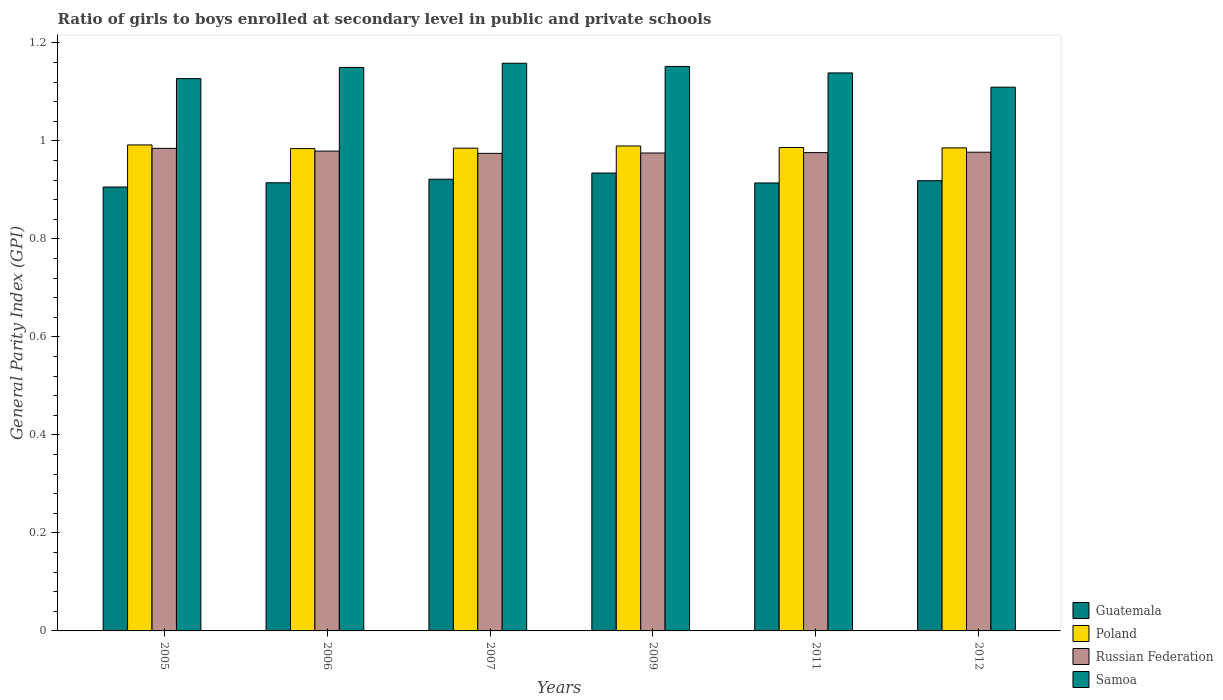How many different coloured bars are there?
Keep it short and to the point. 4. What is the label of the 6th group of bars from the left?
Your response must be concise. 2012. In how many cases, is the number of bars for a given year not equal to the number of legend labels?
Offer a terse response. 0. What is the general parity index in Poland in 2011?
Give a very brief answer. 0.99. Across all years, what is the maximum general parity index in Guatemala?
Offer a very short reply. 0.93. Across all years, what is the minimum general parity index in Guatemala?
Ensure brevity in your answer.  0.91. In which year was the general parity index in Guatemala minimum?
Make the answer very short. 2005. What is the total general parity index in Poland in the graph?
Give a very brief answer. 5.92. What is the difference between the general parity index in Russian Federation in 2006 and that in 2012?
Provide a succinct answer. 0. What is the difference between the general parity index in Samoa in 2007 and the general parity index in Russian Federation in 2011?
Make the answer very short. 0.18. What is the average general parity index in Samoa per year?
Offer a terse response. 1.14. In the year 2005, what is the difference between the general parity index in Poland and general parity index in Russian Federation?
Offer a terse response. 0.01. In how many years, is the general parity index in Guatemala greater than 1.04?
Ensure brevity in your answer.  0. What is the ratio of the general parity index in Russian Federation in 2009 to that in 2011?
Keep it short and to the point. 1. Is the difference between the general parity index in Poland in 2007 and 2009 greater than the difference between the general parity index in Russian Federation in 2007 and 2009?
Make the answer very short. No. What is the difference between the highest and the second highest general parity index in Poland?
Your response must be concise. 0. What is the difference between the highest and the lowest general parity index in Guatemala?
Give a very brief answer. 0.03. In how many years, is the general parity index in Poland greater than the average general parity index in Poland taken over all years?
Provide a succinct answer. 2. Is the sum of the general parity index in Russian Federation in 2009 and 2011 greater than the maximum general parity index in Guatemala across all years?
Your answer should be compact. Yes. What does the 1st bar from the left in 2011 represents?
Your answer should be compact. Guatemala. What does the 3rd bar from the right in 2011 represents?
Ensure brevity in your answer.  Poland. What is the difference between two consecutive major ticks on the Y-axis?
Ensure brevity in your answer.  0.2. How many legend labels are there?
Make the answer very short. 4. How are the legend labels stacked?
Your answer should be compact. Vertical. What is the title of the graph?
Provide a short and direct response. Ratio of girls to boys enrolled at secondary level in public and private schools. Does "Channel Islands" appear as one of the legend labels in the graph?
Offer a terse response. No. What is the label or title of the X-axis?
Ensure brevity in your answer.  Years. What is the label or title of the Y-axis?
Give a very brief answer. General Parity Index (GPI). What is the General Parity Index (GPI) in Guatemala in 2005?
Offer a very short reply. 0.91. What is the General Parity Index (GPI) of Poland in 2005?
Your response must be concise. 0.99. What is the General Parity Index (GPI) of Russian Federation in 2005?
Provide a succinct answer. 0.98. What is the General Parity Index (GPI) in Samoa in 2005?
Offer a terse response. 1.13. What is the General Parity Index (GPI) of Guatemala in 2006?
Provide a short and direct response. 0.91. What is the General Parity Index (GPI) of Poland in 2006?
Provide a succinct answer. 0.98. What is the General Parity Index (GPI) of Russian Federation in 2006?
Provide a succinct answer. 0.98. What is the General Parity Index (GPI) of Samoa in 2006?
Your response must be concise. 1.15. What is the General Parity Index (GPI) of Guatemala in 2007?
Your response must be concise. 0.92. What is the General Parity Index (GPI) of Poland in 2007?
Offer a very short reply. 0.99. What is the General Parity Index (GPI) of Russian Federation in 2007?
Make the answer very short. 0.97. What is the General Parity Index (GPI) of Samoa in 2007?
Offer a very short reply. 1.16. What is the General Parity Index (GPI) of Guatemala in 2009?
Give a very brief answer. 0.93. What is the General Parity Index (GPI) in Poland in 2009?
Your answer should be compact. 0.99. What is the General Parity Index (GPI) of Russian Federation in 2009?
Offer a very short reply. 0.98. What is the General Parity Index (GPI) of Samoa in 2009?
Your response must be concise. 1.15. What is the General Parity Index (GPI) in Guatemala in 2011?
Offer a very short reply. 0.91. What is the General Parity Index (GPI) in Poland in 2011?
Offer a very short reply. 0.99. What is the General Parity Index (GPI) of Russian Federation in 2011?
Your answer should be compact. 0.98. What is the General Parity Index (GPI) of Samoa in 2011?
Give a very brief answer. 1.14. What is the General Parity Index (GPI) of Guatemala in 2012?
Ensure brevity in your answer.  0.92. What is the General Parity Index (GPI) in Poland in 2012?
Make the answer very short. 0.99. What is the General Parity Index (GPI) of Russian Federation in 2012?
Your response must be concise. 0.98. What is the General Parity Index (GPI) in Samoa in 2012?
Ensure brevity in your answer.  1.11. Across all years, what is the maximum General Parity Index (GPI) in Guatemala?
Make the answer very short. 0.93. Across all years, what is the maximum General Parity Index (GPI) in Poland?
Provide a succinct answer. 0.99. Across all years, what is the maximum General Parity Index (GPI) in Russian Federation?
Provide a short and direct response. 0.98. Across all years, what is the maximum General Parity Index (GPI) of Samoa?
Offer a terse response. 1.16. Across all years, what is the minimum General Parity Index (GPI) in Guatemala?
Ensure brevity in your answer.  0.91. Across all years, what is the minimum General Parity Index (GPI) in Poland?
Give a very brief answer. 0.98. Across all years, what is the minimum General Parity Index (GPI) of Russian Federation?
Give a very brief answer. 0.97. Across all years, what is the minimum General Parity Index (GPI) in Samoa?
Provide a short and direct response. 1.11. What is the total General Parity Index (GPI) in Guatemala in the graph?
Provide a succinct answer. 5.51. What is the total General Parity Index (GPI) in Poland in the graph?
Make the answer very short. 5.92. What is the total General Parity Index (GPI) of Russian Federation in the graph?
Make the answer very short. 5.87. What is the total General Parity Index (GPI) of Samoa in the graph?
Your answer should be compact. 6.84. What is the difference between the General Parity Index (GPI) in Guatemala in 2005 and that in 2006?
Your response must be concise. -0.01. What is the difference between the General Parity Index (GPI) in Poland in 2005 and that in 2006?
Provide a short and direct response. 0.01. What is the difference between the General Parity Index (GPI) in Russian Federation in 2005 and that in 2006?
Offer a very short reply. 0.01. What is the difference between the General Parity Index (GPI) in Samoa in 2005 and that in 2006?
Make the answer very short. -0.02. What is the difference between the General Parity Index (GPI) of Guatemala in 2005 and that in 2007?
Offer a terse response. -0.02. What is the difference between the General Parity Index (GPI) in Poland in 2005 and that in 2007?
Keep it short and to the point. 0.01. What is the difference between the General Parity Index (GPI) of Russian Federation in 2005 and that in 2007?
Make the answer very short. 0.01. What is the difference between the General Parity Index (GPI) in Samoa in 2005 and that in 2007?
Offer a terse response. -0.03. What is the difference between the General Parity Index (GPI) in Guatemala in 2005 and that in 2009?
Give a very brief answer. -0.03. What is the difference between the General Parity Index (GPI) in Poland in 2005 and that in 2009?
Make the answer very short. 0. What is the difference between the General Parity Index (GPI) in Russian Federation in 2005 and that in 2009?
Give a very brief answer. 0.01. What is the difference between the General Parity Index (GPI) of Samoa in 2005 and that in 2009?
Offer a terse response. -0.02. What is the difference between the General Parity Index (GPI) in Guatemala in 2005 and that in 2011?
Your response must be concise. -0.01. What is the difference between the General Parity Index (GPI) in Poland in 2005 and that in 2011?
Your response must be concise. 0.01. What is the difference between the General Parity Index (GPI) in Russian Federation in 2005 and that in 2011?
Make the answer very short. 0.01. What is the difference between the General Parity Index (GPI) in Samoa in 2005 and that in 2011?
Offer a very short reply. -0.01. What is the difference between the General Parity Index (GPI) in Guatemala in 2005 and that in 2012?
Your answer should be very brief. -0.01. What is the difference between the General Parity Index (GPI) of Poland in 2005 and that in 2012?
Provide a short and direct response. 0.01. What is the difference between the General Parity Index (GPI) in Russian Federation in 2005 and that in 2012?
Offer a very short reply. 0.01. What is the difference between the General Parity Index (GPI) in Samoa in 2005 and that in 2012?
Give a very brief answer. 0.02. What is the difference between the General Parity Index (GPI) in Guatemala in 2006 and that in 2007?
Provide a succinct answer. -0.01. What is the difference between the General Parity Index (GPI) of Poland in 2006 and that in 2007?
Your response must be concise. -0. What is the difference between the General Parity Index (GPI) of Russian Federation in 2006 and that in 2007?
Keep it short and to the point. 0. What is the difference between the General Parity Index (GPI) in Samoa in 2006 and that in 2007?
Provide a short and direct response. -0.01. What is the difference between the General Parity Index (GPI) of Guatemala in 2006 and that in 2009?
Give a very brief answer. -0.02. What is the difference between the General Parity Index (GPI) of Poland in 2006 and that in 2009?
Give a very brief answer. -0.01. What is the difference between the General Parity Index (GPI) in Russian Federation in 2006 and that in 2009?
Offer a terse response. 0. What is the difference between the General Parity Index (GPI) in Samoa in 2006 and that in 2009?
Keep it short and to the point. -0. What is the difference between the General Parity Index (GPI) of Guatemala in 2006 and that in 2011?
Provide a short and direct response. 0. What is the difference between the General Parity Index (GPI) of Poland in 2006 and that in 2011?
Give a very brief answer. -0. What is the difference between the General Parity Index (GPI) in Russian Federation in 2006 and that in 2011?
Offer a very short reply. 0. What is the difference between the General Parity Index (GPI) of Samoa in 2006 and that in 2011?
Your response must be concise. 0.01. What is the difference between the General Parity Index (GPI) of Guatemala in 2006 and that in 2012?
Offer a very short reply. -0. What is the difference between the General Parity Index (GPI) of Poland in 2006 and that in 2012?
Your response must be concise. -0. What is the difference between the General Parity Index (GPI) in Russian Federation in 2006 and that in 2012?
Provide a short and direct response. 0. What is the difference between the General Parity Index (GPI) of Samoa in 2006 and that in 2012?
Offer a very short reply. 0.04. What is the difference between the General Parity Index (GPI) of Guatemala in 2007 and that in 2009?
Your response must be concise. -0.01. What is the difference between the General Parity Index (GPI) of Poland in 2007 and that in 2009?
Give a very brief answer. -0. What is the difference between the General Parity Index (GPI) in Russian Federation in 2007 and that in 2009?
Your response must be concise. -0. What is the difference between the General Parity Index (GPI) of Samoa in 2007 and that in 2009?
Your answer should be very brief. 0.01. What is the difference between the General Parity Index (GPI) in Guatemala in 2007 and that in 2011?
Offer a very short reply. 0.01. What is the difference between the General Parity Index (GPI) in Poland in 2007 and that in 2011?
Provide a succinct answer. -0. What is the difference between the General Parity Index (GPI) of Russian Federation in 2007 and that in 2011?
Your answer should be compact. -0. What is the difference between the General Parity Index (GPI) in Samoa in 2007 and that in 2011?
Give a very brief answer. 0.02. What is the difference between the General Parity Index (GPI) in Guatemala in 2007 and that in 2012?
Your answer should be compact. 0. What is the difference between the General Parity Index (GPI) of Poland in 2007 and that in 2012?
Offer a terse response. -0. What is the difference between the General Parity Index (GPI) of Russian Federation in 2007 and that in 2012?
Your response must be concise. -0. What is the difference between the General Parity Index (GPI) of Samoa in 2007 and that in 2012?
Offer a terse response. 0.05. What is the difference between the General Parity Index (GPI) of Guatemala in 2009 and that in 2011?
Give a very brief answer. 0.02. What is the difference between the General Parity Index (GPI) in Poland in 2009 and that in 2011?
Offer a very short reply. 0. What is the difference between the General Parity Index (GPI) in Russian Federation in 2009 and that in 2011?
Ensure brevity in your answer.  -0. What is the difference between the General Parity Index (GPI) of Samoa in 2009 and that in 2011?
Give a very brief answer. 0.01. What is the difference between the General Parity Index (GPI) in Guatemala in 2009 and that in 2012?
Ensure brevity in your answer.  0.02. What is the difference between the General Parity Index (GPI) of Poland in 2009 and that in 2012?
Your answer should be very brief. 0. What is the difference between the General Parity Index (GPI) of Russian Federation in 2009 and that in 2012?
Offer a terse response. -0. What is the difference between the General Parity Index (GPI) in Samoa in 2009 and that in 2012?
Your answer should be compact. 0.04. What is the difference between the General Parity Index (GPI) in Guatemala in 2011 and that in 2012?
Make the answer very short. -0. What is the difference between the General Parity Index (GPI) of Poland in 2011 and that in 2012?
Your response must be concise. 0. What is the difference between the General Parity Index (GPI) of Russian Federation in 2011 and that in 2012?
Your answer should be very brief. -0. What is the difference between the General Parity Index (GPI) in Samoa in 2011 and that in 2012?
Keep it short and to the point. 0.03. What is the difference between the General Parity Index (GPI) in Guatemala in 2005 and the General Parity Index (GPI) in Poland in 2006?
Provide a short and direct response. -0.08. What is the difference between the General Parity Index (GPI) of Guatemala in 2005 and the General Parity Index (GPI) of Russian Federation in 2006?
Provide a short and direct response. -0.07. What is the difference between the General Parity Index (GPI) in Guatemala in 2005 and the General Parity Index (GPI) in Samoa in 2006?
Give a very brief answer. -0.24. What is the difference between the General Parity Index (GPI) in Poland in 2005 and the General Parity Index (GPI) in Russian Federation in 2006?
Ensure brevity in your answer.  0.01. What is the difference between the General Parity Index (GPI) of Poland in 2005 and the General Parity Index (GPI) of Samoa in 2006?
Make the answer very short. -0.16. What is the difference between the General Parity Index (GPI) in Russian Federation in 2005 and the General Parity Index (GPI) in Samoa in 2006?
Ensure brevity in your answer.  -0.17. What is the difference between the General Parity Index (GPI) of Guatemala in 2005 and the General Parity Index (GPI) of Poland in 2007?
Your answer should be very brief. -0.08. What is the difference between the General Parity Index (GPI) of Guatemala in 2005 and the General Parity Index (GPI) of Russian Federation in 2007?
Make the answer very short. -0.07. What is the difference between the General Parity Index (GPI) in Guatemala in 2005 and the General Parity Index (GPI) in Samoa in 2007?
Provide a succinct answer. -0.25. What is the difference between the General Parity Index (GPI) in Poland in 2005 and the General Parity Index (GPI) in Russian Federation in 2007?
Give a very brief answer. 0.02. What is the difference between the General Parity Index (GPI) of Poland in 2005 and the General Parity Index (GPI) of Samoa in 2007?
Your answer should be very brief. -0.17. What is the difference between the General Parity Index (GPI) in Russian Federation in 2005 and the General Parity Index (GPI) in Samoa in 2007?
Your answer should be compact. -0.17. What is the difference between the General Parity Index (GPI) of Guatemala in 2005 and the General Parity Index (GPI) of Poland in 2009?
Make the answer very short. -0.08. What is the difference between the General Parity Index (GPI) in Guatemala in 2005 and the General Parity Index (GPI) in Russian Federation in 2009?
Keep it short and to the point. -0.07. What is the difference between the General Parity Index (GPI) of Guatemala in 2005 and the General Parity Index (GPI) of Samoa in 2009?
Give a very brief answer. -0.25. What is the difference between the General Parity Index (GPI) of Poland in 2005 and the General Parity Index (GPI) of Russian Federation in 2009?
Keep it short and to the point. 0.02. What is the difference between the General Parity Index (GPI) in Poland in 2005 and the General Parity Index (GPI) in Samoa in 2009?
Provide a succinct answer. -0.16. What is the difference between the General Parity Index (GPI) of Russian Federation in 2005 and the General Parity Index (GPI) of Samoa in 2009?
Keep it short and to the point. -0.17. What is the difference between the General Parity Index (GPI) of Guatemala in 2005 and the General Parity Index (GPI) of Poland in 2011?
Provide a short and direct response. -0.08. What is the difference between the General Parity Index (GPI) of Guatemala in 2005 and the General Parity Index (GPI) of Russian Federation in 2011?
Your response must be concise. -0.07. What is the difference between the General Parity Index (GPI) in Guatemala in 2005 and the General Parity Index (GPI) in Samoa in 2011?
Offer a terse response. -0.23. What is the difference between the General Parity Index (GPI) of Poland in 2005 and the General Parity Index (GPI) of Russian Federation in 2011?
Make the answer very short. 0.02. What is the difference between the General Parity Index (GPI) in Poland in 2005 and the General Parity Index (GPI) in Samoa in 2011?
Offer a terse response. -0.15. What is the difference between the General Parity Index (GPI) of Russian Federation in 2005 and the General Parity Index (GPI) of Samoa in 2011?
Ensure brevity in your answer.  -0.15. What is the difference between the General Parity Index (GPI) in Guatemala in 2005 and the General Parity Index (GPI) in Poland in 2012?
Provide a succinct answer. -0.08. What is the difference between the General Parity Index (GPI) of Guatemala in 2005 and the General Parity Index (GPI) of Russian Federation in 2012?
Make the answer very short. -0.07. What is the difference between the General Parity Index (GPI) in Guatemala in 2005 and the General Parity Index (GPI) in Samoa in 2012?
Offer a terse response. -0.2. What is the difference between the General Parity Index (GPI) in Poland in 2005 and the General Parity Index (GPI) in Russian Federation in 2012?
Provide a short and direct response. 0.01. What is the difference between the General Parity Index (GPI) in Poland in 2005 and the General Parity Index (GPI) in Samoa in 2012?
Keep it short and to the point. -0.12. What is the difference between the General Parity Index (GPI) in Russian Federation in 2005 and the General Parity Index (GPI) in Samoa in 2012?
Your answer should be compact. -0.12. What is the difference between the General Parity Index (GPI) of Guatemala in 2006 and the General Parity Index (GPI) of Poland in 2007?
Keep it short and to the point. -0.07. What is the difference between the General Parity Index (GPI) of Guatemala in 2006 and the General Parity Index (GPI) of Russian Federation in 2007?
Give a very brief answer. -0.06. What is the difference between the General Parity Index (GPI) of Guatemala in 2006 and the General Parity Index (GPI) of Samoa in 2007?
Keep it short and to the point. -0.24. What is the difference between the General Parity Index (GPI) in Poland in 2006 and the General Parity Index (GPI) in Russian Federation in 2007?
Give a very brief answer. 0.01. What is the difference between the General Parity Index (GPI) of Poland in 2006 and the General Parity Index (GPI) of Samoa in 2007?
Keep it short and to the point. -0.17. What is the difference between the General Parity Index (GPI) of Russian Federation in 2006 and the General Parity Index (GPI) of Samoa in 2007?
Your answer should be very brief. -0.18. What is the difference between the General Parity Index (GPI) in Guatemala in 2006 and the General Parity Index (GPI) in Poland in 2009?
Give a very brief answer. -0.08. What is the difference between the General Parity Index (GPI) of Guatemala in 2006 and the General Parity Index (GPI) of Russian Federation in 2009?
Offer a terse response. -0.06. What is the difference between the General Parity Index (GPI) in Guatemala in 2006 and the General Parity Index (GPI) in Samoa in 2009?
Provide a succinct answer. -0.24. What is the difference between the General Parity Index (GPI) of Poland in 2006 and the General Parity Index (GPI) of Russian Federation in 2009?
Your response must be concise. 0.01. What is the difference between the General Parity Index (GPI) in Poland in 2006 and the General Parity Index (GPI) in Samoa in 2009?
Your answer should be very brief. -0.17. What is the difference between the General Parity Index (GPI) of Russian Federation in 2006 and the General Parity Index (GPI) of Samoa in 2009?
Your answer should be very brief. -0.17. What is the difference between the General Parity Index (GPI) of Guatemala in 2006 and the General Parity Index (GPI) of Poland in 2011?
Provide a short and direct response. -0.07. What is the difference between the General Parity Index (GPI) in Guatemala in 2006 and the General Parity Index (GPI) in Russian Federation in 2011?
Offer a very short reply. -0.06. What is the difference between the General Parity Index (GPI) of Guatemala in 2006 and the General Parity Index (GPI) of Samoa in 2011?
Provide a short and direct response. -0.22. What is the difference between the General Parity Index (GPI) in Poland in 2006 and the General Parity Index (GPI) in Russian Federation in 2011?
Keep it short and to the point. 0.01. What is the difference between the General Parity Index (GPI) of Poland in 2006 and the General Parity Index (GPI) of Samoa in 2011?
Provide a succinct answer. -0.15. What is the difference between the General Parity Index (GPI) in Russian Federation in 2006 and the General Parity Index (GPI) in Samoa in 2011?
Your response must be concise. -0.16. What is the difference between the General Parity Index (GPI) of Guatemala in 2006 and the General Parity Index (GPI) of Poland in 2012?
Give a very brief answer. -0.07. What is the difference between the General Parity Index (GPI) in Guatemala in 2006 and the General Parity Index (GPI) in Russian Federation in 2012?
Make the answer very short. -0.06. What is the difference between the General Parity Index (GPI) in Guatemala in 2006 and the General Parity Index (GPI) in Samoa in 2012?
Give a very brief answer. -0.2. What is the difference between the General Parity Index (GPI) of Poland in 2006 and the General Parity Index (GPI) of Russian Federation in 2012?
Keep it short and to the point. 0.01. What is the difference between the General Parity Index (GPI) of Poland in 2006 and the General Parity Index (GPI) of Samoa in 2012?
Offer a terse response. -0.13. What is the difference between the General Parity Index (GPI) in Russian Federation in 2006 and the General Parity Index (GPI) in Samoa in 2012?
Provide a short and direct response. -0.13. What is the difference between the General Parity Index (GPI) in Guatemala in 2007 and the General Parity Index (GPI) in Poland in 2009?
Ensure brevity in your answer.  -0.07. What is the difference between the General Parity Index (GPI) in Guatemala in 2007 and the General Parity Index (GPI) in Russian Federation in 2009?
Provide a succinct answer. -0.05. What is the difference between the General Parity Index (GPI) of Guatemala in 2007 and the General Parity Index (GPI) of Samoa in 2009?
Give a very brief answer. -0.23. What is the difference between the General Parity Index (GPI) in Poland in 2007 and the General Parity Index (GPI) in Russian Federation in 2009?
Provide a short and direct response. 0.01. What is the difference between the General Parity Index (GPI) of Poland in 2007 and the General Parity Index (GPI) of Samoa in 2009?
Your answer should be compact. -0.17. What is the difference between the General Parity Index (GPI) of Russian Federation in 2007 and the General Parity Index (GPI) of Samoa in 2009?
Ensure brevity in your answer.  -0.18. What is the difference between the General Parity Index (GPI) in Guatemala in 2007 and the General Parity Index (GPI) in Poland in 2011?
Your answer should be very brief. -0.06. What is the difference between the General Parity Index (GPI) in Guatemala in 2007 and the General Parity Index (GPI) in Russian Federation in 2011?
Offer a very short reply. -0.05. What is the difference between the General Parity Index (GPI) in Guatemala in 2007 and the General Parity Index (GPI) in Samoa in 2011?
Your answer should be compact. -0.22. What is the difference between the General Parity Index (GPI) in Poland in 2007 and the General Parity Index (GPI) in Russian Federation in 2011?
Offer a terse response. 0.01. What is the difference between the General Parity Index (GPI) of Poland in 2007 and the General Parity Index (GPI) of Samoa in 2011?
Offer a terse response. -0.15. What is the difference between the General Parity Index (GPI) in Russian Federation in 2007 and the General Parity Index (GPI) in Samoa in 2011?
Provide a succinct answer. -0.16. What is the difference between the General Parity Index (GPI) of Guatemala in 2007 and the General Parity Index (GPI) of Poland in 2012?
Provide a short and direct response. -0.06. What is the difference between the General Parity Index (GPI) in Guatemala in 2007 and the General Parity Index (GPI) in Russian Federation in 2012?
Ensure brevity in your answer.  -0.06. What is the difference between the General Parity Index (GPI) in Guatemala in 2007 and the General Parity Index (GPI) in Samoa in 2012?
Offer a very short reply. -0.19. What is the difference between the General Parity Index (GPI) of Poland in 2007 and the General Parity Index (GPI) of Russian Federation in 2012?
Offer a very short reply. 0.01. What is the difference between the General Parity Index (GPI) in Poland in 2007 and the General Parity Index (GPI) in Samoa in 2012?
Provide a short and direct response. -0.12. What is the difference between the General Parity Index (GPI) in Russian Federation in 2007 and the General Parity Index (GPI) in Samoa in 2012?
Give a very brief answer. -0.14. What is the difference between the General Parity Index (GPI) in Guatemala in 2009 and the General Parity Index (GPI) in Poland in 2011?
Provide a short and direct response. -0.05. What is the difference between the General Parity Index (GPI) in Guatemala in 2009 and the General Parity Index (GPI) in Russian Federation in 2011?
Provide a succinct answer. -0.04. What is the difference between the General Parity Index (GPI) of Guatemala in 2009 and the General Parity Index (GPI) of Samoa in 2011?
Keep it short and to the point. -0.2. What is the difference between the General Parity Index (GPI) of Poland in 2009 and the General Parity Index (GPI) of Russian Federation in 2011?
Offer a very short reply. 0.01. What is the difference between the General Parity Index (GPI) of Poland in 2009 and the General Parity Index (GPI) of Samoa in 2011?
Give a very brief answer. -0.15. What is the difference between the General Parity Index (GPI) of Russian Federation in 2009 and the General Parity Index (GPI) of Samoa in 2011?
Offer a very short reply. -0.16. What is the difference between the General Parity Index (GPI) in Guatemala in 2009 and the General Parity Index (GPI) in Poland in 2012?
Keep it short and to the point. -0.05. What is the difference between the General Parity Index (GPI) of Guatemala in 2009 and the General Parity Index (GPI) of Russian Federation in 2012?
Your answer should be very brief. -0.04. What is the difference between the General Parity Index (GPI) in Guatemala in 2009 and the General Parity Index (GPI) in Samoa in 2012?
Offer a very short reply. -0.18. What is the difference between the General Parity Index (GPI) in Poland in 2009 and the General Parity Index (GPI) in Russian Federation in 2012?
Keep it short and to the point. 0.01. What is the difference between the General Parity Index (GPI) of Poland in 2009 and the General Parity Index (GPI) of Samoa in 2012?
Your response must be concise. -0.12. What is the difference between the General Parity Index (GPI) of Russian Federation in 2009 and the General Parity Index (GPI) of Samoa in 2012?
Your answer should be very brief. -0.13. What is the difference between the General Parity Index (GPI) of Guatemala in 2011 and the General Parity Index (GPI) of Poland in 2012?
Provide a short and direct response. -0.07. What is the difference between the General Parity Index (GPI) of Guatemala in 2011 and the General Parity Index (GPI) of Russian Federation in 2012?
Keep it short and to the point. -0.06. What is the difference between the General Parity Index (GPI) in Guatemala in 2011 and the General Parity Index (GPI) in Samoa in 2012?
Your answer should be compact. -0.2. What is the difference between the General Parity Index (GPI) in Poland in 2011 and the General Parity Index (GPI) in Russian Federation in 2012?
Your answer should be compact. 0.01. What is the difference between the General Parity Index (GPI) in Poland in 2011 and the General Parity Index (GPI) in Samoa in 2012?
Offer a very short reply. -0.12. What is the difference between the General Parity Index (GPI) in Russian Federation in 2011 and the General Parity Index (GPI) in Samoa in 2012?
Keep it short and to the point. -0.13. What is the average General Parity Index (GPI) of Guatemala per year?
Offer a terse response. 0.92. What is the average General Parity Index (GPI) in Poland per year?
Your answer should be compact. 0.99. What is the average General Parity Index (GPI) of Russian Federation per year?
Make the answer very short. 0.98. What is the average General Parity Index (GPI) in Samoa per year?
Your answer should be very brief. 1.14. In the year 2005, what is the difference between the General Parity Index (GPI) in Guatemala and General Parity Index (GPI) in Poland?
Your response must be concise. -0.09. In the year 2005, what is the difference between the General Parity Index (GPI) in Guatemala and General Parity Index (GPI) in Russian Federation?
Your response must be concise. -0.08. In the year 2005, what is the difference between the General Parity Index (GPI) in Guatemala and General Parity Index (GPI) in Samoa?
Make the answer very short. -0.22. In the year 2005, what is the difference between the General Parity Index (GPI) in Poland and General Parity Index (GPI) in Russian Federation?
Make the answer very short. 0.01. In the year 2005, what is the difference between the General Parity Index (GPI) in Poland and General Parity Index (GPI) in Samoa?
Offer a very short reply. -0.14. In the year 2005, what is the difference between the General Parity Index (GPI) in Russian Federation and General Parity Index (GPI) in Samoa?
Give a very brief answer. -0.14. In the year 2006, what is the difference between the General Parity Index (GPI) in Guatemala and General Parity Index (GPI) in Poland?
Give a very brief answer. -0.07. In the year 2006, what is the difference between the General Parity Index (GPI) of Guatemala and General Parity Index (GPI) of Russian Federation?
Offer a terse response. -0.06. In the year 2006, what is the difference between the General Parity Index (GPI) of Guatemala and General Parity Index (GPI) of Samoa?
Your answer should be compact. -0.24. In the year 2006, what is the difference between the General Parity Index (GPI) in Poland and General Parity Index (GPI) in Russian Federation?
Keep it short and to the point. 0.01. In the year 2006, what is the difference between the General Parity Index (GPI) of Poland and General Parity Index (GPI) of Samoa?
Ensure brevity in your answer.  -0.17. In the year 2006, what is the difference between the General Parity Index (GPI) in Russian Federation and General Parity Index (GPI) in Samoa?
Make the answer very short. -0.17. In the year 2007, what is the difference between the General Parity Index (GPI) in Guatemala and General Parity Index (GPI) in Poland?
Your answer should be compact. -0.06. In the year 2007, what is the difference between the General Parity Index (GPI) of Guatemala and General Parity Index (GPI) of Russian Federation?
Offer a terse response. -0.05. In the year 2007, what is the difference between the General Parity Index (GPI) in Guatemala and General Parity Index (GPI) in Samoa?
Give a very brief answer. -0.24. In the year 2007, what is the difference between the General Parity Index (GPI) in Poland and General Parity Index (GPI) in Russian Federation?
Give a very brief answer. 0.01. In the year 2007, what is the difference between the General Parity Index (GPI) of Poland and General Parity Index (GPI) of Samoa?
Make the answer very short. -0.17. In the year 2007, what is the difference between the General Parity Index (GPI) of Russian Federation and General Parity Index (GPI) of Samoa?
Your answer should be compact. -0.18. In the year 2009, what is the difference between the General Parity Index (GPI) of Guatemala and General Parity Index (GPI) of Poland?
Make the answer very short. -0.06. In the year 2009, what is the difference between the General Parity Index (GPI) in Guatemala and General Parity Index (GPI) in Russian Federation?
Your answer should be very brief. -0.04. In the year 2009, what is the difference between the General Parity Index (GPI) of Guatemala and General Parity Index (GPI) of Samoa?
Your answer should be very brief. -0.22. In the year 2009, what is the difference between the General Parity Index (GPI) of Poland and General Parity Index (GPI) of Russian Federation?
Give a very brief answer. 0.01. In the year 2009, what is the difference between the General Parity Index (GPI) of Poland and General Parity Index (GPI) of Samoa?
Make the answer very short. -0.16. In the year 2009, what is the difference between the General Parity Index (GPI) of Russian Federation and General Parity Index (GPI) of Samoa?
Make the answer very short. -0.18. In the year 2011, what is the difference between the General Parity Index (GPI) in Guatemala and General Parity Index (GPI) in Poland?
Keep it short and to the point. -0.07. In the year 2011, what is the difference between the General Parity Index (GPI) of Guatemala and General Parity Index (GPI) of Russian Federation?
Provide a short and direct response. -0.06. In the year 2011, what is the difference between the General Parity Index (GPI) of Guatemala and General Parity Index (GPI) of Samoa?
Your answer should be compact. -0.22. In the year 2011, what is the difference between the General Parity Index (GPI) of Poland and General Parity Index (GPI) of Russian Federation?
Your answer should be compact. 0.01. In the year 2011, what is the difference between the General Parity Index (GPI) in Poland and General Parity Index (GPI) in Samoa?
Provide a succinct answer. -0.15. In the year 2011, what is the difference between the General Parity Index (GPI) of Russian Federation and General Parity Index (GPI) of Samoa?
Offer a terse response. -0.16. In the year 2012, what is the difference between the General Parity Index (GPI) of Guatemala and General Parity Index (GPI) of Poland?
Your response must be concise. -0.07. In the year 2012, what is the difference between the General Parity Index (GPI) of Guatemala and General Parity Index (GPI) of Russian Federation?
Ensure brevity in your answer.  -0.06. In the year 2012, what is the difference between the General Parity Index (GPI) of Guatemala and General Parity Index (GPI) of Samoa?
Provide a short and direct response. -0.19. In the year 2012, what is the difference between the General Parity Index (GPI) of Poland and General Parity Index (GPI) of Russian Federation?
Offer a very short reply. 0.01. In the year 2012, what is the difference between the General Parity Index (GPI) in Poland and General Parity Index (GPI) in Samoa?
Your response must be concise. -0.12. In the year 2012, what is the difference between the General Parity Index (GPI) of Russian Federation and General Parity Index (GPI) of Samoa?
Provide a succinct answer. -0.13. What is the ratio of the General Parity Index (GPI) of Poland in 2005 to that in 2006?
Your response must be concise. 1.01. What is the ratio of the General Parity Index (GPI) in Samoa in 2005 to that in 2006?
Offer a terse response. 0.98. What is the ratio of the General Parity Index (GPI) in Guatemala in 2005 to that in 2007?
Keep it short and to the point. 0.98. What is the ratio of the General Parity Index (GPI) of Poland in 2005 to that in 2007?
Make the answer very short. 1.01. What is the ratio of the General Parity Index (GPI) in Russian Federation in 2005 to that in 2007?
Your answer should be compact. 1.01. What is the ratio of the General Parity Index (GPI) in Samoa in 2005 to that in 2007?
Keep it short and to the point. 0.97. What is the ratio of the General Parity Index (GPI) in Guatemala in 2005 to that in 2009?
Give a very brief answer. 0.97. What is the ratio of the General Parity Index (GPI) of Russian Federation in 2005 to that in 2009?
Give a very brief answer. 1.01. What is the ratio of the General Parity Index (GPI) in Samoa in 2005 to that in 2009?
Your answer should be very brief. 0.98. What is the ratio of the General Parity Index (GPI) of Guatemala in 2005 to that in 2011?
Offer a terse response. 0.99. What is the ratio of the General Parity Index (GPI) of Russian Federation in 2005 to that in 2011?
Ensure brevity in your answer.  1.01. What is the ratio of the General Parity Index (GPI) in Guatemala in 2005 to that in 2012?
Make the answer very short. 0.99. What is the ratio of the General Parity Index (GPI) in Poland in 2005 to that in 2012?
Keep it short and to the point. 1.01. What is the ratio of the General Parity Index (GPI) of Samoa in 2005 to that in 2012?
Offer a terse response. 1.02. What is the ratio of the General Parity Index (GPI) in Guatemala in 2006 to that in 2007?
Your answer should be compact. 0.99. What is the ratio of the General Parity Index (GPI) in Guatemala in 2006 to that in 2009?
Provide a succinct answer. 0.98. What is the ratio of the General Parity Index (GPI) of Guatemala in 2006 to that in 2011?
Your answer should be compact. 1. What is the ratio of the General Parity Index (GPI) of Russian Federation in 2006 to that in 2011?
Your response must be concise. 1. What is the ratio of the General Parity Index (GPI) in Samoa in 2006 to that in 2011?
Make the answer very short. 1.01. What is the ratio of the General Parity Index (GPI) in Guatemala in 2006 to that in 2012?
Your answer should be compact. 1. What is the ratio of the General Parity Index (GPI) in Russian Federation in 2006 to that in 2012?
Make the answer very short. 1. What is the ratio of the General Parity Index (GPI) in Samoa in 2006 to that in 2012?
Keep it short and to the point. 1.04. What is the ratio of the General Parity Index (GPI) of Guatemala in 2007 to that in 2009?
Ensure brevity in your answer.  0.99. What is the ratio of the General Parity Index (GPI) of Russian Federation in 2007 to that in 2009?
Make the answer very short. 1. What is the ratio of the General Parity Index (GPI) of Samoa in 2007 to that in 2009?
Offer a terse response. 1.01. What is the ratio of the General Parity Index (GPI) in Guatemala in 2007 to that in 2011?
Ensure brevity in your answer.  1.01. What is the ratio of the General Parity Index (GPI) in Russian Federation in 2007 to that in 2011?
Your response must be concise. 1. What is the ratio of the General Parity Index (GPI) in Samoa in 2007 to that in 2011?
Offer a terse response. 1.02. What is the ratio of the General Parity Index (GPI) in Poland in 2007 to that in 2012?
Provide a succinct answer. 1. What is the ratio of the General Parity Index (GPI) in Russian Federation in 2007 to that in 2012?
Your answer should be compact. 1. What is the ratio of the General Parity Index (GPI) in Samoa in 2007 to that in 2012?
Ensure brevity in your answer.  1.04. What is the ratio of the General Parity Index (GPI) in Guatemala in 2009 to that in 2011?
Offer a very short reply. 1.02. What is the ratio of the General Parity Index (GPI) of Poland in 2009 to that in 2011?
Your response must be concise. 1. What is the ratio of the General Parity Index (GPI) of Russian Federation in 2009 to that in 2011?
Your answer should be compact. 1. What is the ratio of the General Parity Index (GPI) of Samoa in 2009 to that in 2011?
Offer a very short reply. 1.01. What is the ratio of the General Parity Index (GPI) of Russian Federation in 2009 to that in 2012?
Ensure brevity in your answer.  1. What is the ratio of the General Parity Index (GPI) of Samoa in 2009 to that in 2012?
Provide a short and direct response. 1.04. What is the ratio of the General Parity Index (GPI) of Russian Federation in 2011 to that in 2012?
Provide a succinct answer. 1. What is the ratio of the General Parity Index (GPI) of Samoa in 2011 to that in 2012?
Give a very brief answer. 1.03. What is the difference between the highest and the second highest General Parity Index (GPI) in Guatemala?
Your response must be concise. 0.01. What is the difference between the highest and the second highest General Parity Index (GPI) of Poland?
Keep it short and to the point. 0. What is the difference between the highest and the second highest General Parity Index (GPI) in Russian Federation?
Make the answer very short. 0.01. What is the difference between the highest and the second highest General Parity Index (GPI) of Samoa?
Your answer should be very brief. 0.01. What is the difference between the highest and the lowest General Parity Index (GPI) of Guatemala?
Offer a very short reply. 0.03. What is the difference between the highest and the lowest General Parity Index (GPI) of Poland?
Offer a terse response. 0.01. What is the difference between the highest and the lowest General Parity Index (GPI) in Russian Federation?
Ensure brevity in your answer.  0.01. What is the difference between the highest and the lowest General Parity Index (GPI) of Samoa?
Give a very brief answer. 0.05. 